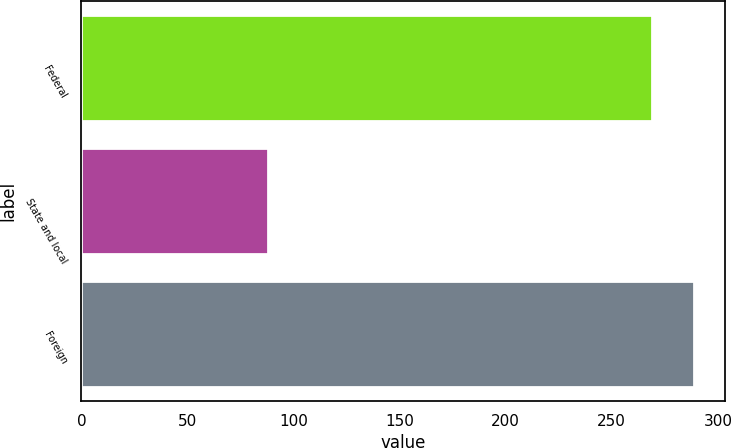<chart> <loc_0><loc_0><loc_500><loc_500><bar_chart><fcel>Federal<fcel>State and local<fcel>Foreign<nl><fcel>269<fcel>88<fcel>288.7<nl></chart> 